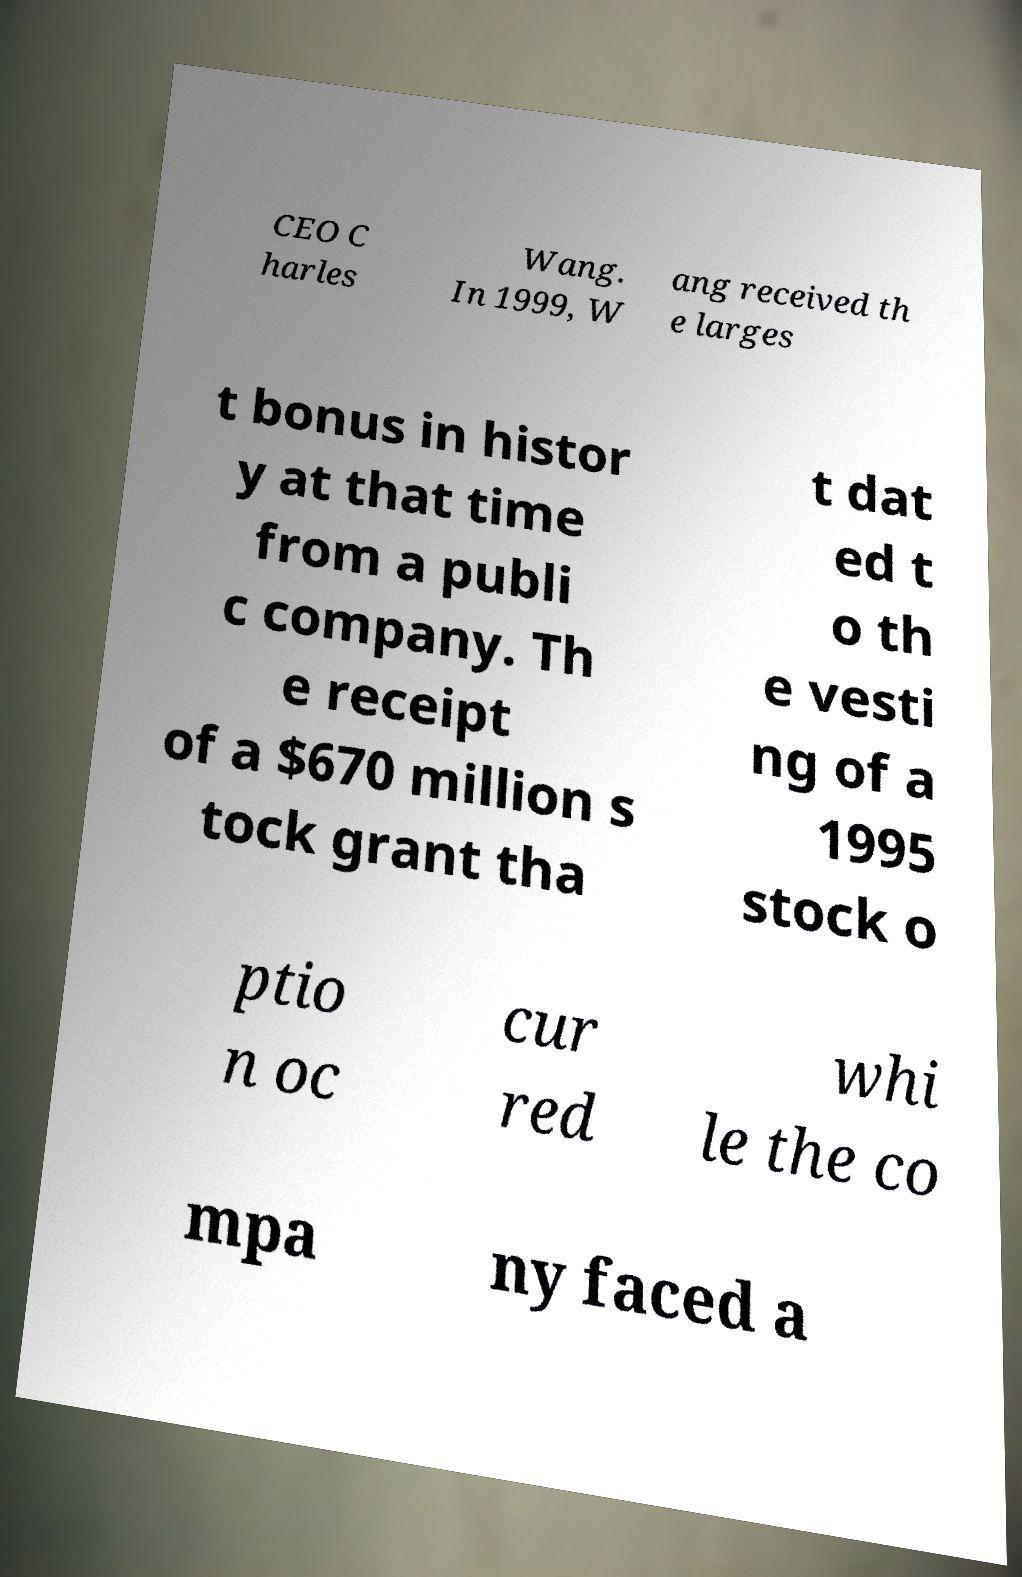Can you read and provide the text displayed in the image?This photo seems to have some interesting text. Can you extract and type it out for me? CEO C harles Wang. In 1999, W ang received th e larges t bonus in histor y at that time from a publi c company. Th e receipt of a $670 million s tock grant tha t dat ed t o th e vesti ng of a 1995 stock o ptio n oc cur red whi le the co mpa ny faced a 